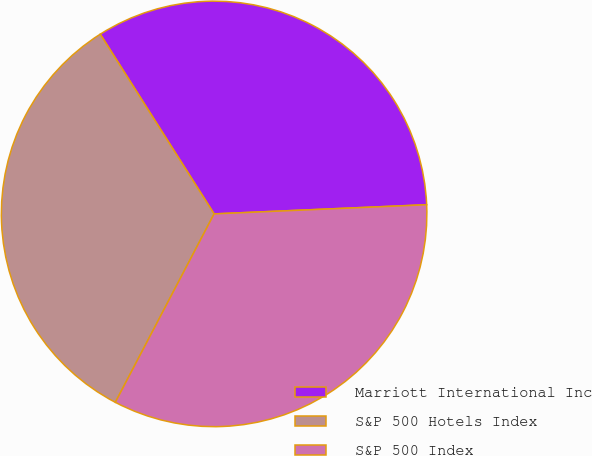Convert chart. <chart><loc_0><loc_0><loc_500><loc_500><pie_chart><fcel>Marriott International Inc<fcel>S&P 500 Hotels Index<fcel>S&P 500 Index<nl><fcel>33.3%<fcel>33.33%<fcel>33.37%<nl></chart> 